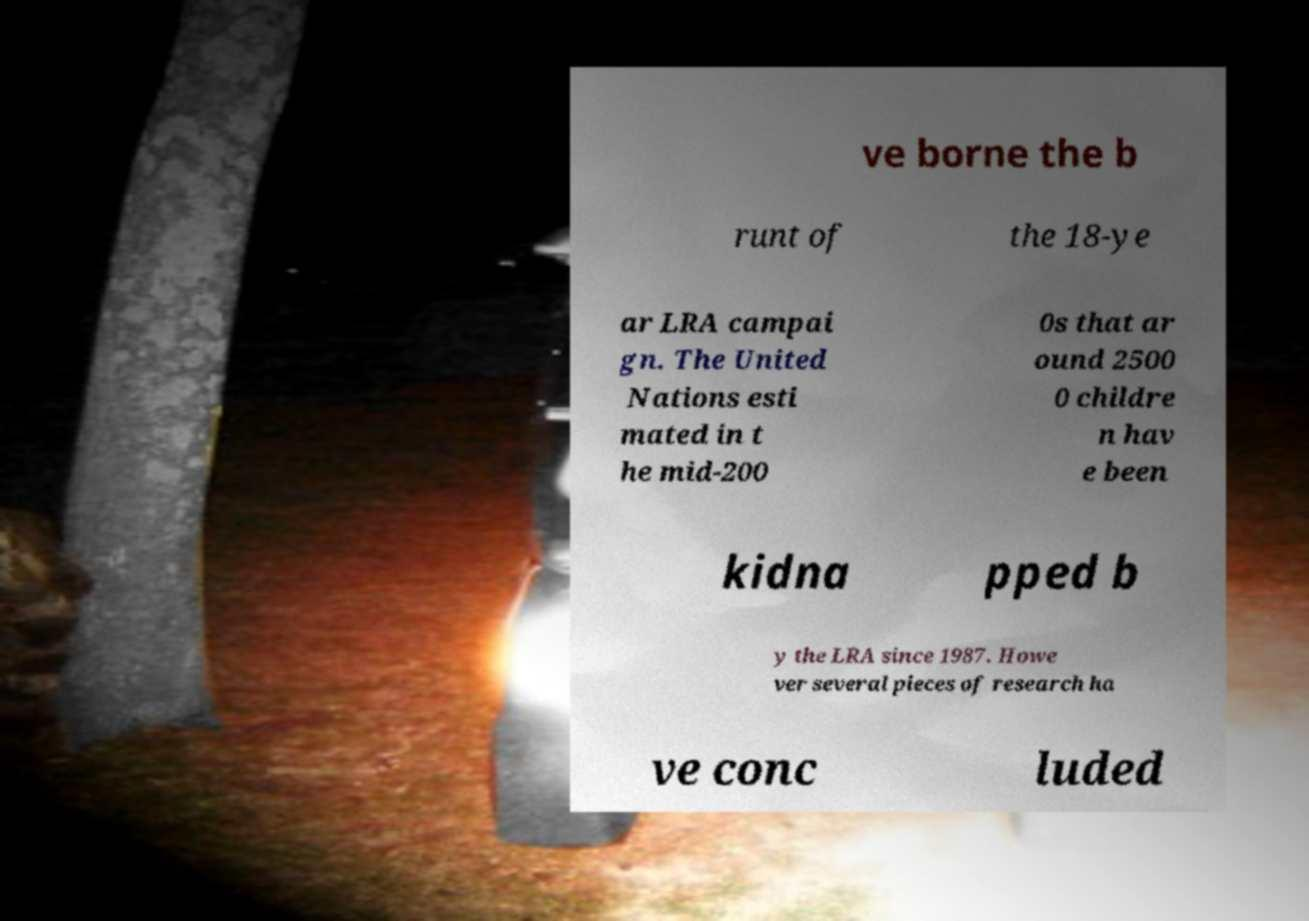Please identify and transcribe the text found in this image. ve borne the b runt of the 18-ye ar LRA campai gn. The United Nations esti mated in t he mid-200 0s that ar ound 2500 0 childre n hav e been kidna pped b y the LRA since 1987. Howe ver several pieces of research ha ve conc luded 